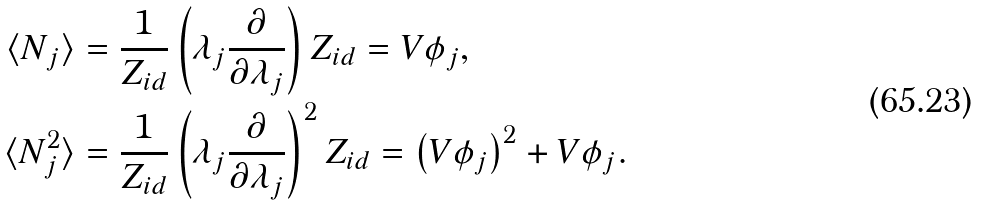Convert formula to latex. <formula><loc_0><loc_0><loc_500><loc_500>\langle N _ { j } \rangle & = \frac { 1 } { Z _ { i d } } \left ( \lambda _ { j } \frac { \partial } { \partial \lambda _ { j } } \right ) Z _ { i d } = V \phi _ { j } , \\ \langle N _ { j } ^ { 2 } \rangle & = \frac { 1 } { Z _ { i d } } \left ( \lambda _ { j } \frac { \partial } { \partial \lambda _ { j } } \right ) ^ { 2 } Z _ { i d } = \left ( V \phi _ { j } \right ) ^ { 2 } + V \phi _ { j } .</formula> 